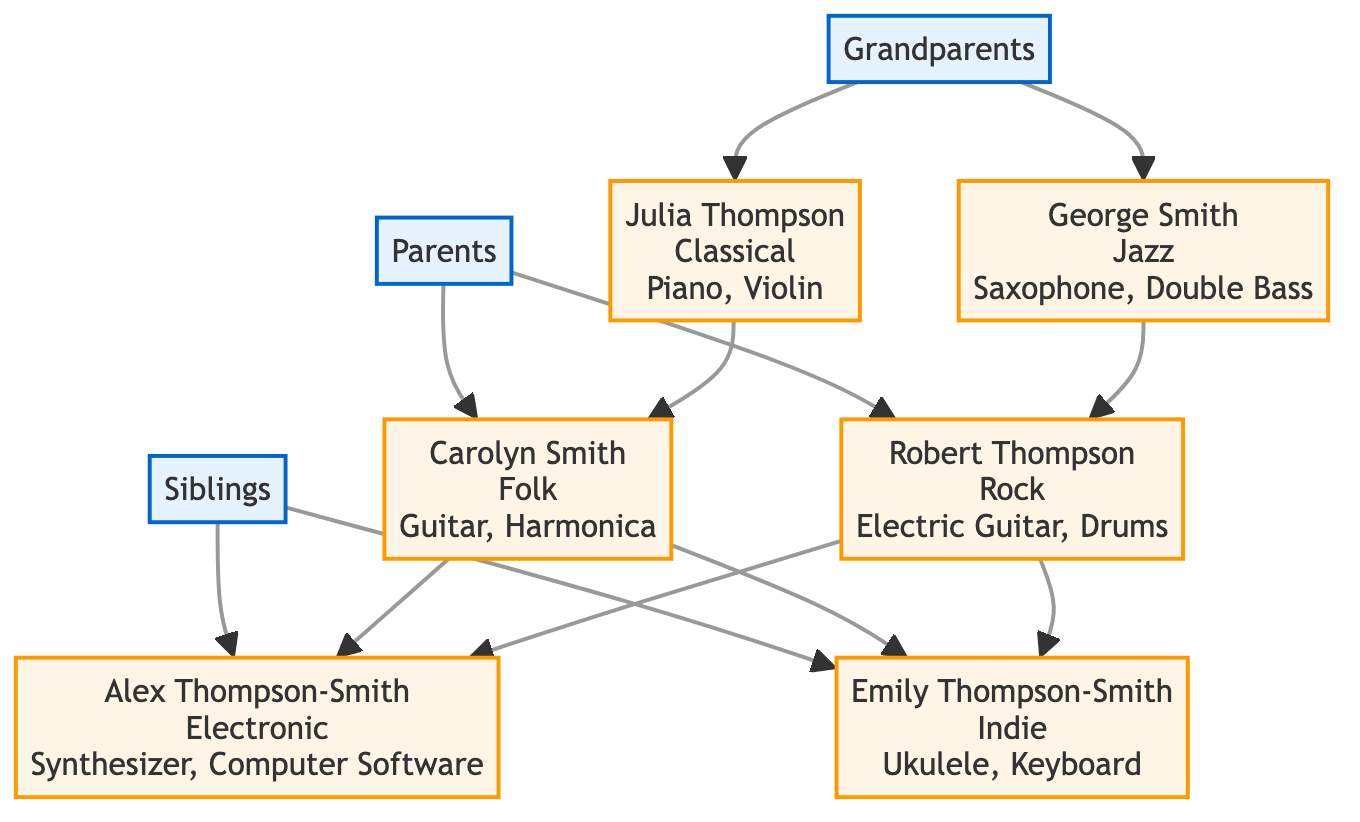What is the main genre of Julia Thompson? Julia Thompson is identified in the diagram as a grandparent and has a main genre of "Classical."
Answer: Classical How many instruments does George Smith play? George Smith is listed with two instruments: "Saxophone" and "Double Bass." Thus, the total number of instruments he plays is 2.
Answer: 2 What is the influence of Carolyn Smith? The diagram states that Carolyn Smith is influenced by "Bob Dylan" and "Joan Baez," which directly notes her musical influences.
Answer: Bob Dylan, Joan Baez Who are the parents of Alex Thompson-Smith? The diagram shows that Alex Thompson-Smith is the child of Carolyn Smith and Robert Thompson.
Answer: Carolyn Smith, Robert Thompson What is the main genre of Emily Thompson-Smith? In the diagram, Emily Thompson-Smith is described with the main genre of "Indie."
Answer: Indie Which instrument is not played by George Smith? George Smith plays "Saxophone" and "Double Bass," thus an instrument that is not listed and therefore not played by him is "Piano," for example.
Answer: Piano Which musical genre is influenced by The Beatles? The diagram indicates that Robert Thompson, Alex Thompson-Smith's father, represents "Rock," which is influenced by The Beatles.
Answer: Rock How many siblings does Alex Thompson-Smith have? The diagram indicates there is one sibling, Emily Thompson-Smith, thus the number of siblings Alex has is 1.
Answer: 1 What instruments does Alex Thompson-Smith use? Alex Thompson-Smith is noted to use "Synthesizer" and "Computer Software," which gives us his primary instruments.
Answer: Synthesizer, Computer Software How many musical genres are represented in Alex's family tree? In the diagram, the distinct musical genres listed are Classical, Jazz, Folk, Rock, Electronic, and Indie, making a total of 6 unique genres.
Answer: 6 